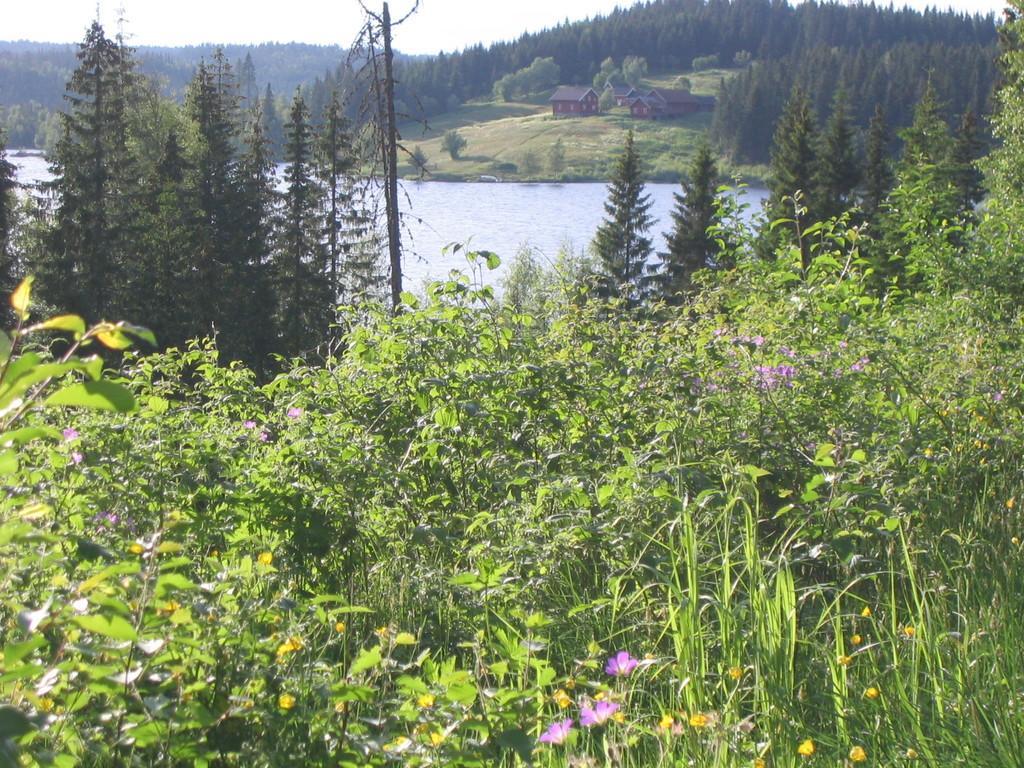Can you describe this image briefly? This picture is clicked outside. In the foreground we can see the plants and flowers. In the center we can see the trees, water body, green grass, plants and some houses. In the background we can see the sky and the trees. 